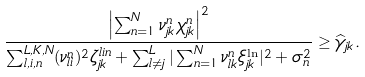Convert formula to latex. <formula><loc_0><loc_0><loc_500><loc_500>\frac { \left | \sum _ { n = 1 } ^ { N } \nu _ { j k } ^ { n } \chi _ { j k } ^ { n } \right | ^ { 2 } } { \sum _ { l , i , n } ^ { L , K , N } ( \nu _ { l i } ^ { n } ) ^ { 2 } \zeta _ { j k } ^ { l i n } + \sum _ { l \neq j } ^ { L } | \sum _ { n = 1 } ^ { N } \nu _ { l k } ^ { n } \xi _ { j k } ^ { \ln } | ^ { 2 } + \sigma _ { n } ^ { 2 } } \geq \widehat { \gamma } _ { j k } .</formula> 